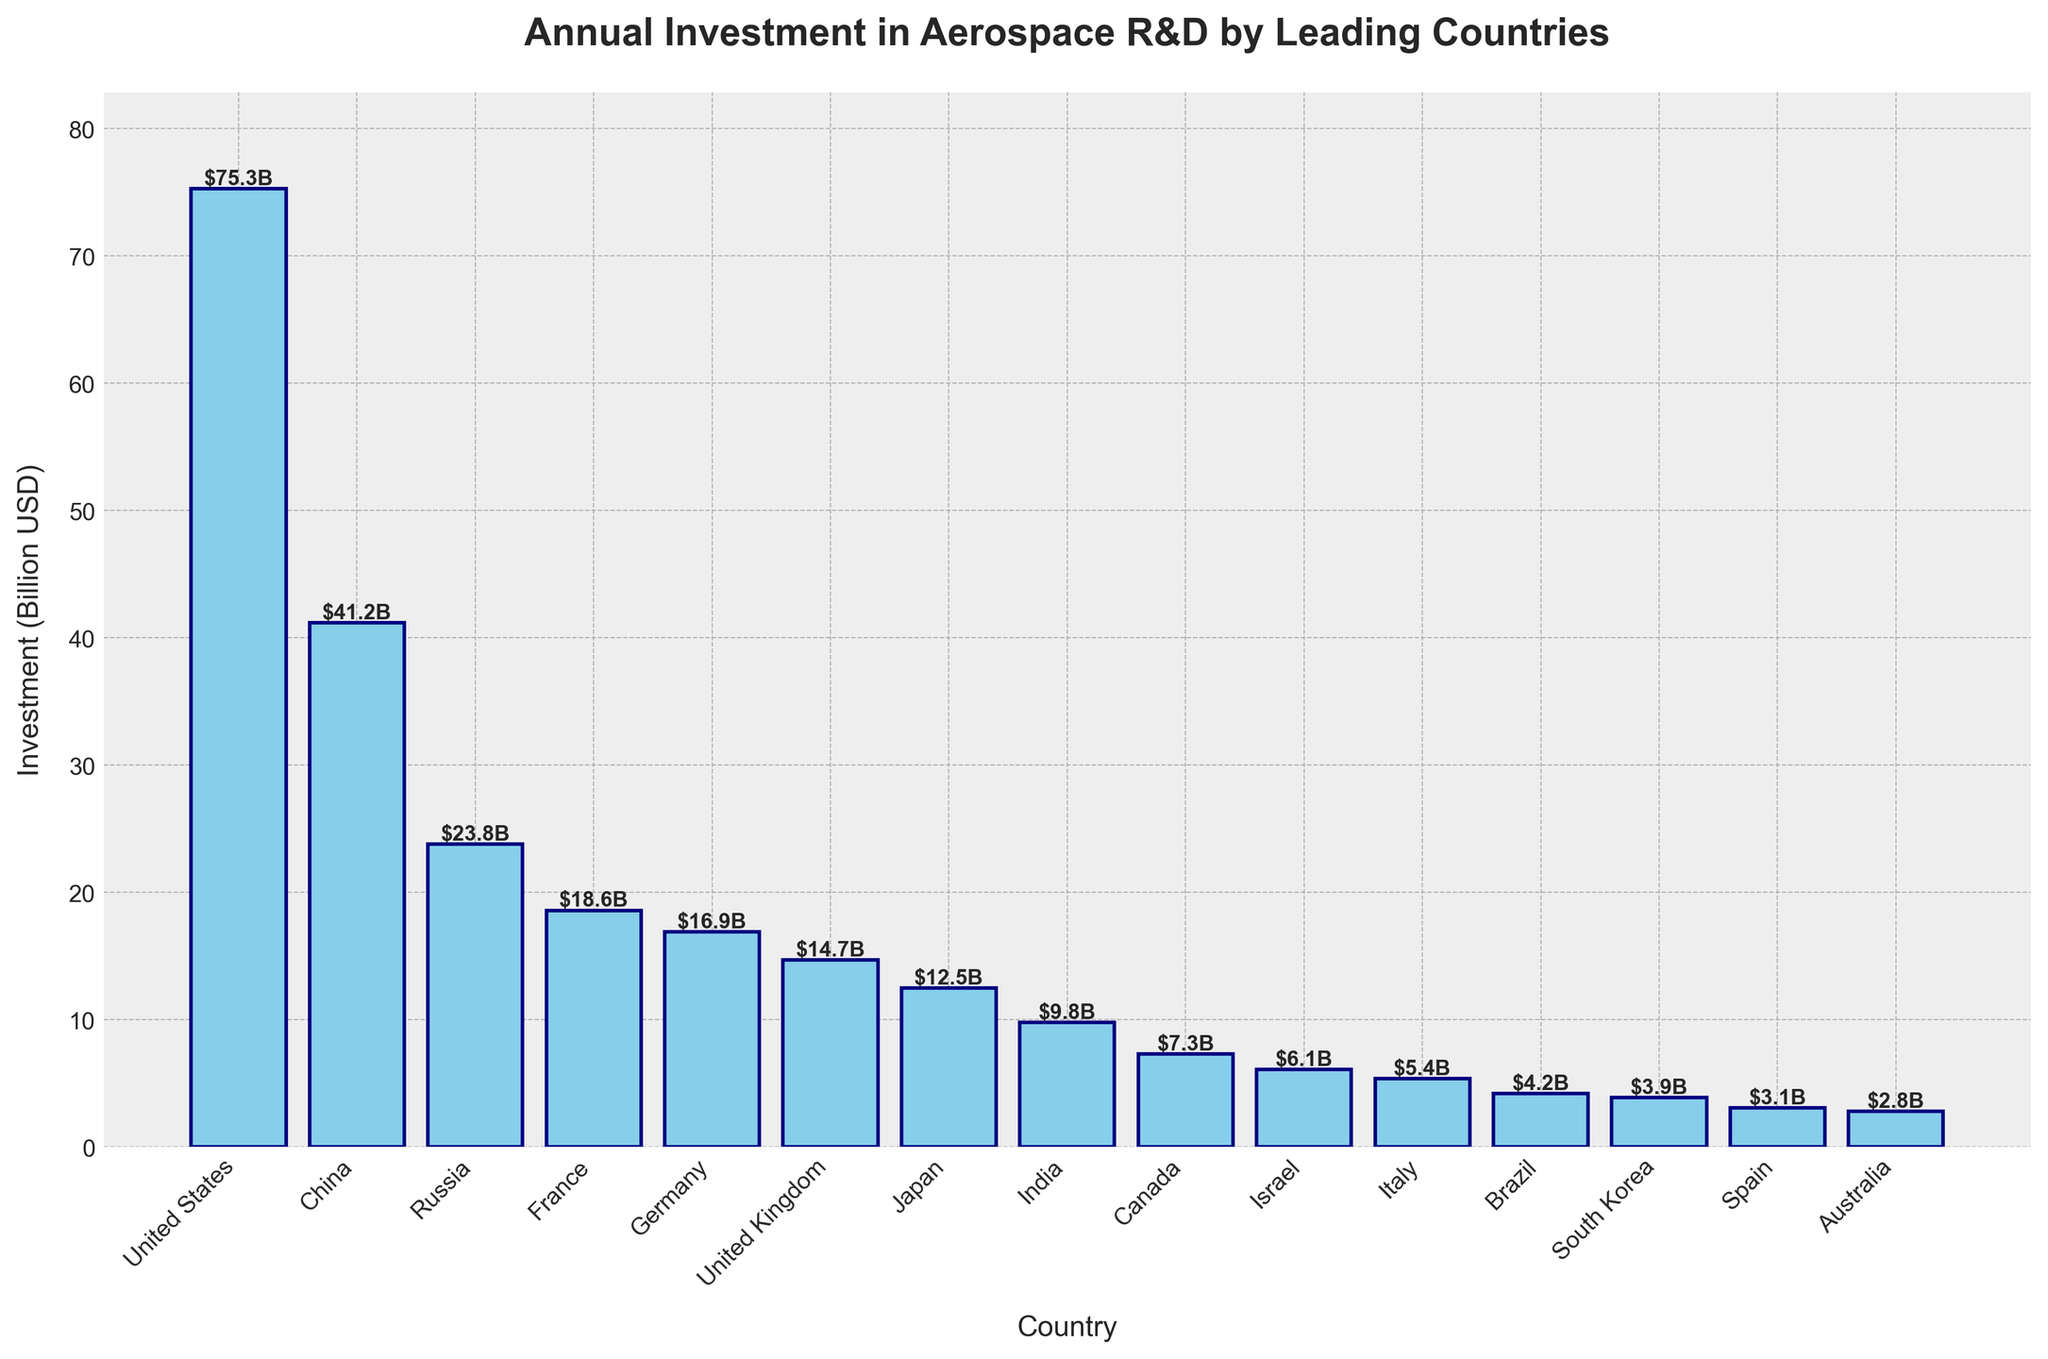Which country has the highest annual investment in aerospace R&D? The bar chart shows the United States with the tallest bar, indicating its investment is the highest at $75.3 billion.
Answer: United States Which country invests more: Germany or United Kingdom? Comparing the heights of the bars for Germany and United Kingdom, Germany's bar representing $16.9 billion is taller than United Kingdom's at $14.7 billion.
Answer: Germany How many countries have an annual investment in aerospace R&D that is greater than $20 billion? Observing the chart, only three countries (United States, China, and Russia) have bars representing investments greater than $20 billion.
Answer: 3 What's the sum of annual investments by France, Germany, and the United Kingdom? France has $18.6 billion, Germany has $16.9 billion, and the United Kingdom has $14.7 billion. Adding these amounts: $18.6B + $16.9B + $14.7B = $50.2 billion.
Answer: $50.2 billion What's the difference in annual investment between China and France? China invests $41.2 billion and France invests $18.6 billion. The difference is $41.2B - $18.6B = $22.6 billion.
Answer: $22.6 billion Which country invests less: Japan or India? Comparing the bars for Japan and India, Japan invests $12.5 billion while India invests $9.8 billion. Therefore, India's investment is less.
Answer: India Is the combined investment of Canada and Italy greater than that of Germany? Canada invests $7.3 billion and Italy invests $5.4 billion, their combined investment is $7.3B + $5.4B = $12.7 billion, which is less than Germany's $16.9 billion.
Answer: No What percentage of the United States' investment is China's investment? China's investment is $41.2 billion and the United States' investment is $75.3 billion. The percentage is ($41.2B / $75.3B) * 100 ≈ 54.7%.
Answer: ~54.7% How many countries invest less than $10 billion annually in aerospace R&D? Countries investing less than $10 billion are India, Canada, Israel, Italy, Brazil, South Korea, Spain, and Australia. Counting these, there are 8 countries.
Answer: 8 